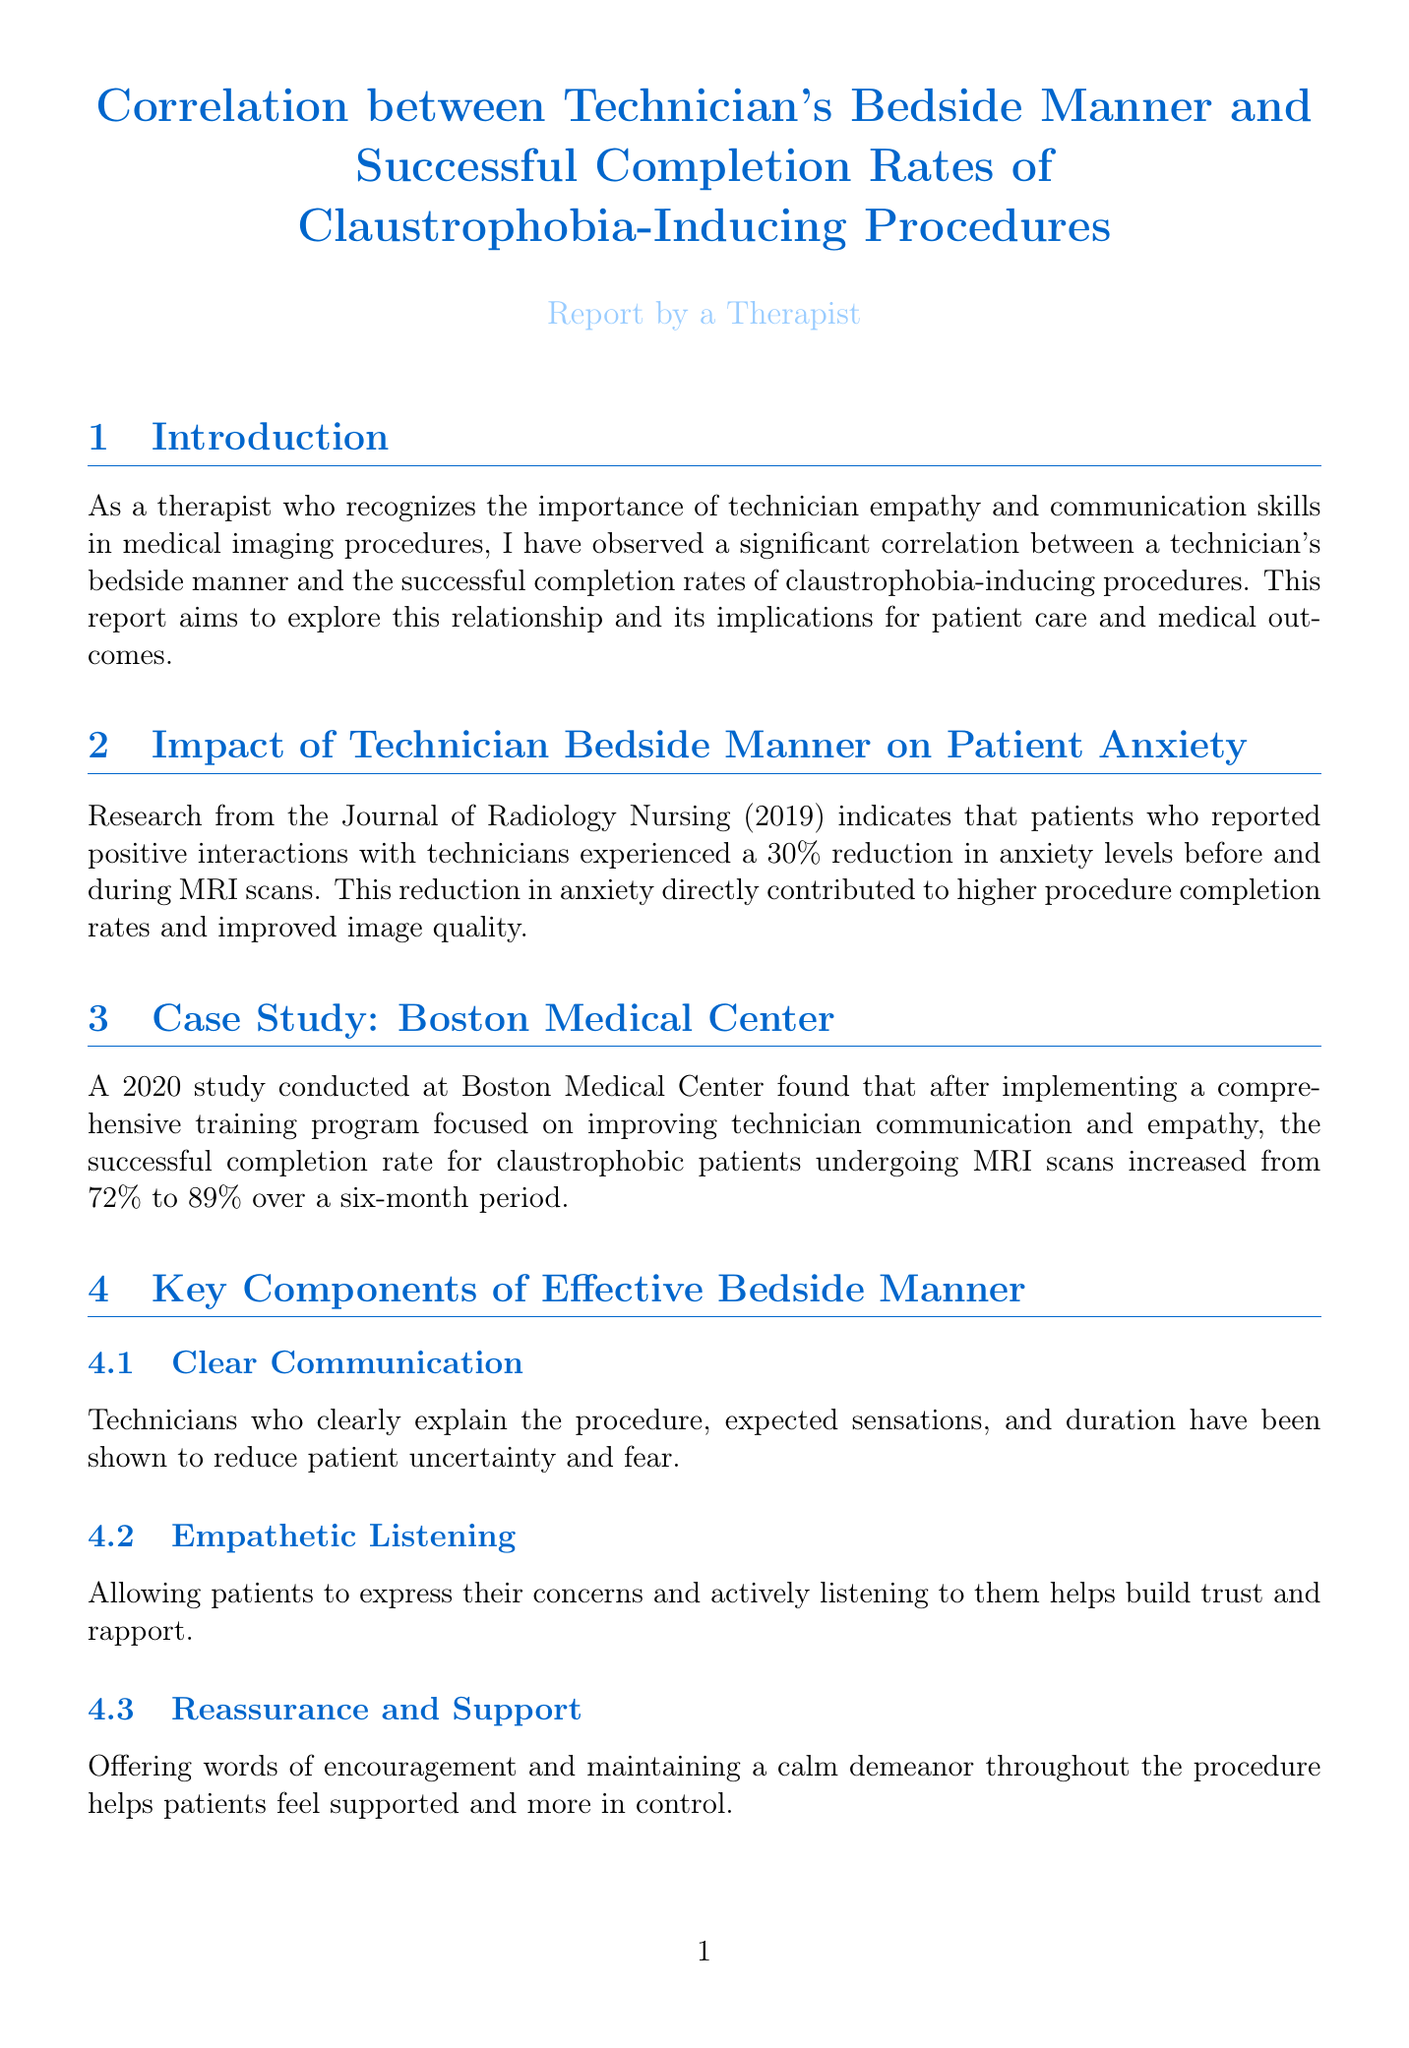What is the main focus of the report? The report aims to explore the correlation between technician's bedside manner and the successful completion rates of claustrophobia-inducing procedures.
Answer: Technician's bedside manner and successful completion rates What was the reduction in anxiety levels due to positive interactions with technicians? The report cites research indicating a 30% reduction in anxiety levels due to positive technician interactions.
Answer: 30% What was the successful completion rate for claustrophobic patients at Boston Medical Center after training? The successful completion rate increased from 72% to 89% after technician training.
Answer: 89% Which organization offers a 'Patient Care in Imaging' course? The American Society of Radiologic Technologists (ASRT) offers this training course.
Answer: American Society of Radiologic Technologists (ASRT) What financial benefit can improved completion rates bring to hospitals annually? The report mentions that improved completion rates could save hospitals up to $500,000 annually.
Answer: $500,000 Which psychological techniques does the report recommend to complement technician training? The report suggests incorporating basic cognitive-behavioral techniques, such as relaxation exercises and guided imagery.
Answer: Relaxation exercises and guided imagery What is a key component of effective bedside manner according to the document? The document identifies clear communication as a key component of effective bedside manner.
Answer: Clear communication Who provided a testimonial regarding their experience with a technician? The patient testimonial in the report is from Sarah Johnson, who underwent an MRI.
Answer: Sarah Johnson What year was the study conducted at Boston Medical Center published? The study at Boston Medical Center was conducted in 2020.
Answer: 2020 